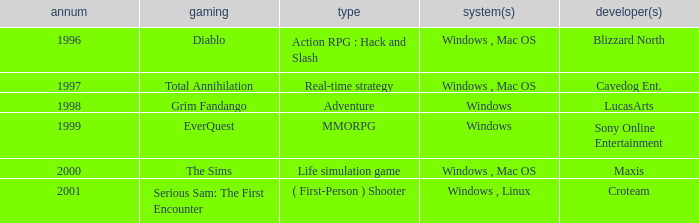What game in the genre of adventure, has a windows platform and its year is after 1997? Grim Fandango. 